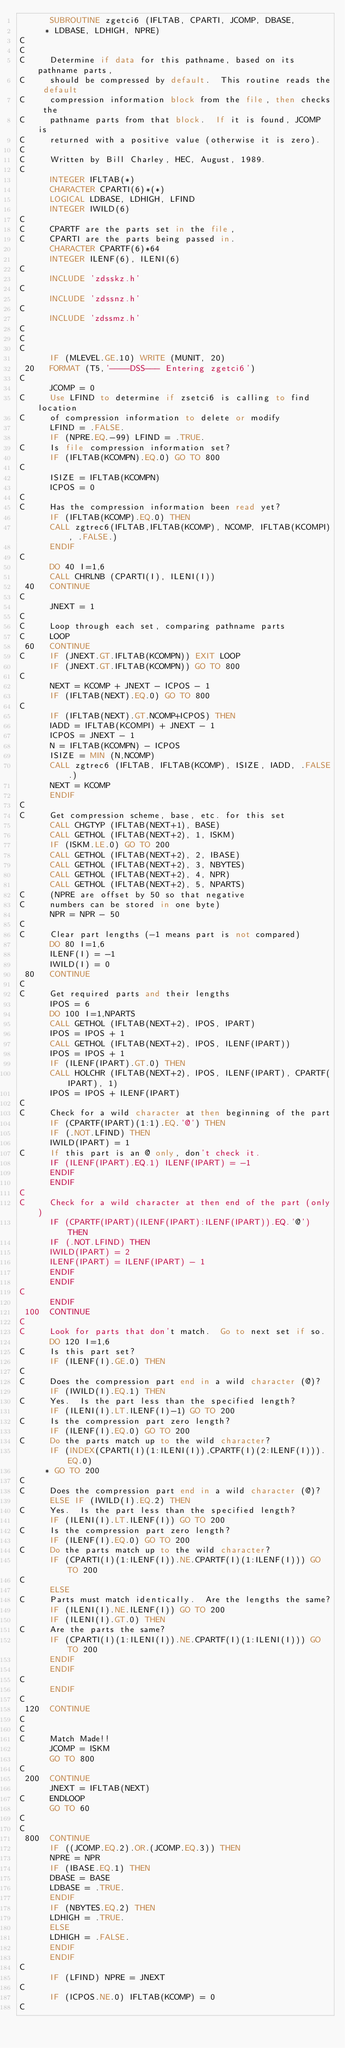Convert code to text. <code><loc_0><loc_0><loc_500><loc_500><_FORTRAN_>      SUBROUTINE zgetci6 (IFLTAB, CPARTI, JCOMP, DBASE,
     * LDBASE, LDHIGH, NPRE)
C
C
C     Determine if data for this pathname, based on its pathname parts,
C     should be compressed by default.  This routine reads the default
C     compression information block from the file, then checks the
C     pathname parts from that block.  If it is found, JCOMP is
C     returned with a positive value (otherwise it is zero).
C
C     Written by Bill Charley, HEC, August, 1989.
C
      INTEGER IFLTAB(*)
      CHARACTER CPARTI(6)*(*)
      LOGICAL LDBASE, LDHIGH, LFIND
      INTEGER IWILD(6)
C
C     CPARTF are the parts set in the file,
C     CPARTI are the parts being passed in.
      CHARACTER CPARTF(6)*64
      INTEGER ILENF(6), ILENI(6)
C
      INCLUDE 'zdsskz.h'
C
      INCLUDE 'zdssnz.h'
C
      INCLUDE 'zdssmz.h'
C
C
C
      IF (MLEVEL.GE.10) WRITE (MUNIT, 20)
 20   FORMAT (T5,'----DSS--- Entering zgetci6')
C
      JCOMP = 0
C     Use LFIND to determine if zsetci6 is calling to find location
C     of compression information to delete or modify
      LFIND = .FALSE.
      IF (NPRE.EQ.-99) LFIND = .TRUE.
C     Is file compression information set?
      IF (IFLTAB(KCOMPN).EQ.0) GO TO 800
C
      ISIZE = IFLTAB(KCOMPN)
      ICPOS = 0
C
C     Has the compression information been read yet?
      IF (IFLTAB(KCOMP).EQ.0) THEN
      CALL zgtrec6(IFLTAB,IFLTAB(KCOMP), NCOMP, IFLTAB(KCOMPI), .FALSE.)
      ENDIF
C
      DO 40 I=1,6
      CALL CHRLNB (CPARTI(I), ILENI(I))
 40   CONTINUE
C
      JNEXT = 1
C
C     Loop through each set, comparing pathname parts
C     LOOP
 60   CONTINUE
C     IF (JNEXT.GT.IFLTAB(KCOMPN)) EXIT LOOP
      IF (JNEXT.GT.IFLTAB(KCOMPN)) GO TO 800
C
      NEXT = KCOMP + JNEXT - ICPOS - 1
      IF (IFLTAB(NEXT).EQ.0) GO TO 800
C
      IF (IFLTAB(NEXT).GT.NCOMP+ICPOS) THEN
      IADD = IFLTAB(KCOMPI) + JNEXT - 1
      ICPOS = JNEXT - 1
      N = IFLTAB(KCOMPN) - ICPOS
      ISIZE = MIN (N,NCOMP)
      CALL zgtrec6 (IFLTAB, IFLTAB(KCOMP), ISIZE, IADD, .FALSE.)
      NEXT = KCOMP
      ENDIF
C
C     Get compression scheme, base, etc. for this set
      CALL CHGTYP (IFLTAB(NEXT+1), BASE)
      CALL GETHOL (IFLTAB(NEXT+2), 1, ISKM)
      IF (ISKM.LE.0) GO TO 200
      CALL GETHOL (IFLTAB(NEXT+2), 2, IBASE)
      CALL GETHOL (IFLTAB(NEXT+2), 3, NBYTES)
      CALL GETHOL (IFLTAB(NEXT+2), 4, NPR)
      CALL GETHOL (IFLTAB(NEXT+2), 5, NPARTS)
C     (NPRE are offset by 50 so that negative
C     numbers can be stored in one byte)
      NPR = NPR - 50
C
C     Clear part lengths (-1 means part is not compared)
      DO 80 I=1,6
      ILENF(I) = -1
      IWILD(I) = 0
 80   CONTINUE
C
C     Get required parts and their lengths
      IPOS = 6
      DO 100 I=1,NPARTS
      CALL GETHOL (IFLTAB(NEXT+2), IPOS, IPART)
      IPOS = IPOS + 1
      CALL GETHOL (IFLTAB(NEXT+2), IPOS, ILENF(IPART))
      IPOS = IPOS + 1
      IF (ILENF(IPART).GT.0) THEN
      CALL HOLCHR (IFLTAB(NEXT+2), IPOS, ILENF(IPART), CPARTF(IPART), 1)
      IPOS = IPOS + ILENF(IPART)
C
C     Check for a wild character at then beginning of the part
      IF (CPARTF(IPART)(1:1).EQ.'@') THEN
      IF (.NOT.LFIND) THEN
      IWILD(IPART) = 1
C     If this part is an @ only, don't check it.
      IF (ILENF(IPART).EQ.1) ILENF(IPART) = -1
      ENDIF
      ENDIF
C
C     Check for a wild character at then end of the part (only)
      IF (CPARTF(IPART)(ILENF(IPART):ILENF(IPART)).EQ.'@') THEN
      IF (.NOT.LFIND) THEN
      IWILD(IPART) = 2
      ILENF(IPART) = ILENF(IPART) - 1
      ENDIF
      ENDIF
C
      ENDIF
 100  CONTINUE
C
C     Look for parts that don't match.  Go to next set if so.
      DO 120 I=1,6
C     Is this part set?
      IF (ILENF(I).GE.0) THEN
C
C     Does the compression part end in a wild character (@)?
      IF (IWILD(I).EQ.1) THEN
C     Yes.  Is the part less than the specified length?
      IF (ILENI(I).LT.ILENF(I)-1) GO TO 200
C     Is the compression part zero length?
      IF (ILENF(I).EQ.0) GO TO 200
C     Do the parts match up to the wild character?
      IF (INDEX(CPARTI(I)(1:ILENI(I)),CPARTF(I)(2:ILENF(I))).EQ.0)
     * GO TO 200
C
C     Does the compression part end in a wild character (@)?
      ELSE IF (IWILD(I).EQ.2) THEN
C     Yes.  Is the part less than the specified length?
      IF (ILENI(I).LT.ILENF(I)) GO TO 200
C     Is the compression part zero length?
      IF (ILENF(I).EQ.0) GO TO 200
C     Do the parts match up to the wild character?
      IF (CPARTI(I)(1:ILENF(I)).NE.CPARTF(I)(1:ILENF(I))) GO TO 200
C
      ELSE
C     Parts must match identically.  Are the lengths the same?
      IF (ILENI(I).NE.ILENF(I)) GO TO 200
      IF (ILENI(I).GT.0) THEN
C     Are the parts the same?
      IF (CPARTI(I)(1:ILENI(I)).NE.CPARTF(I)(1:ILENI(I))) GO TO 200
      ENDIF
      ENDIF
C
      ENDIF
C
 120  CONTINUE
C
C
C     Match Made!!
      JCOMP = ISKM
      GO TO 800
C
 200  CONTINUE
      JNEXT = IFLTAB(NEXT)
C     ENDLOOP
      GO TO 60
C
C
 800  CONTINUE
      IF ((JCOMP.EQ.2).OR.(JCOMP.EQ.3)) THEN
      NPRE = NPR
      IF (IBASE.EQ.1) THEN
      DBASE = BASE
      LDBASE = .TRUE.
      ENDIF
      IF (NBYTES.EQ.2) THEN
      LDHIGH = .TRUE.
      ELSE
      LDHIGH = .FALSE.
      ENDIF
      ENDIF
C
      IF (LFIND) NPRE = JNEXT
C
      IF (ICPOS.NE.0) IFLTAB(KCOMP) = 0
C</code> 